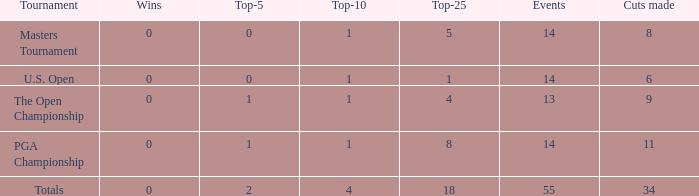What is the highest events when the cuts made is less than 34, the top-25 is less than 5 and the top-10 is more than 1? None. 